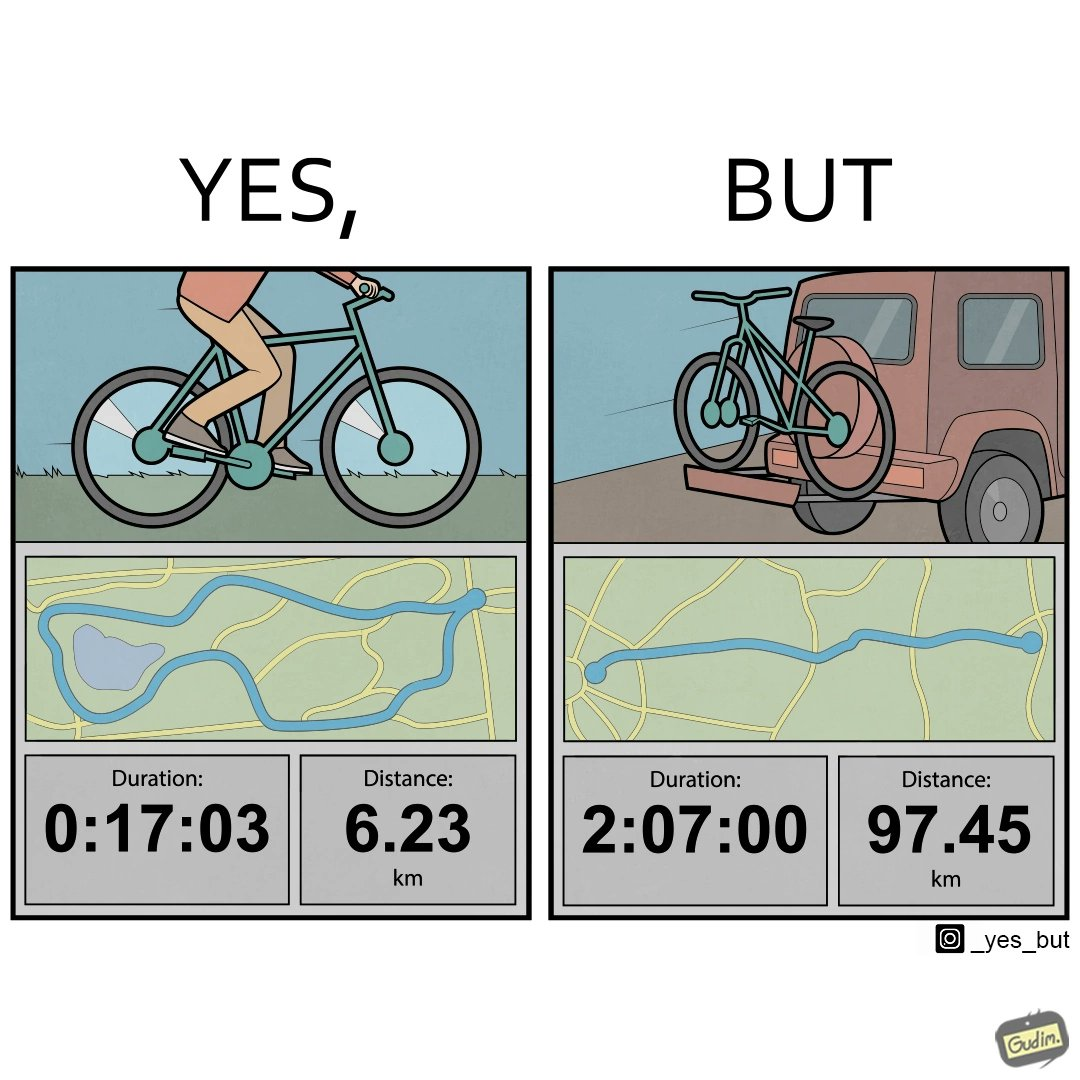Provide a description of this image. The image is ironic, because the person has to travel 2 hours just to ride his bicycle for 17 minutes 